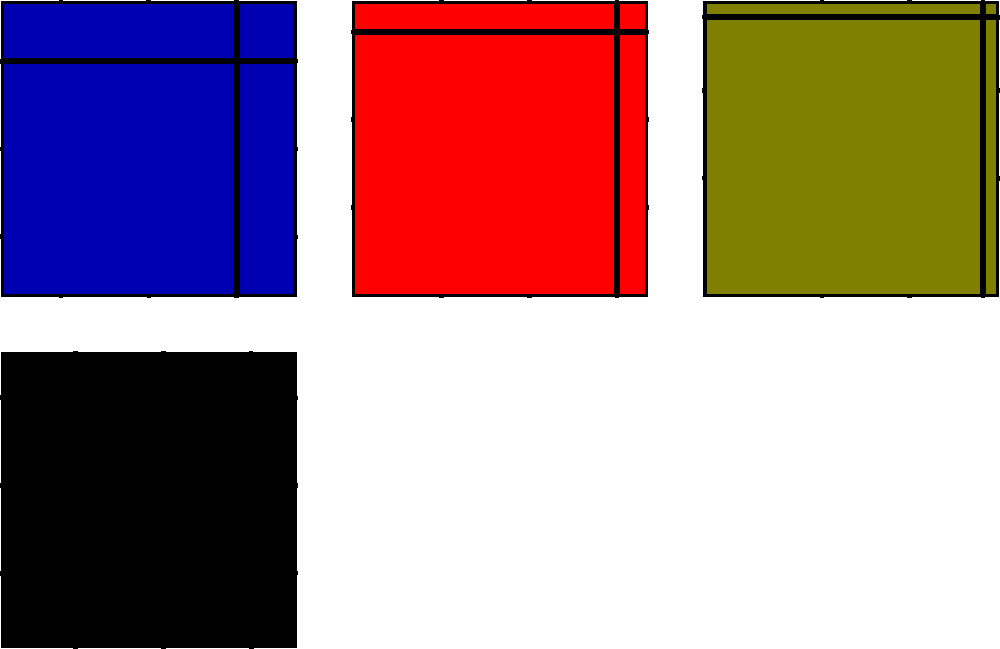Which of the following tartans is most likely associated with the MacLeod clan, known for their distinctive yellow and black pattern? To identify the MacLeod clan tartan, we need to follow these steps:

1. Recall that the MacLeod clan tartan is known for its distinctive yellow and black pattern.

2. Examine each tartan swatch in the image:
   a. Top-left: Green, red, and blue colors
   b. Top-middle: Yellow, black, and red colors
   c. Top-right: Teal, purple, and olive colors
   d. Bottom-left: Various shades of gray and black

3. Compare the colors of each swatch to the known MacLeod tartan characteristics:
   a. Top-left: Does not match (no yellow or black)
   b. Top-middle: Matches (contains yellow and black)
   c. Top-right: Does not match (no yellow or black)
   d. Bottom-left: Does not match (no yellow)

4. Conclude that the top-middle tartan swatch is the most likely to be associated with the MacLeod clan, as it is the only one featuring the distinctive yellow and black pattern.
Answer: Top-middle tartan 